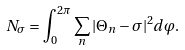<formula> <loc_0><loc_0><loc_500><loc_500>N _ { \sigma } = \int _ { 0 } ^ { 2 \pi } \sum _ { n } | \Theta _ { n } - \sigma | ^ { 2 } d \varphi .</formula> 